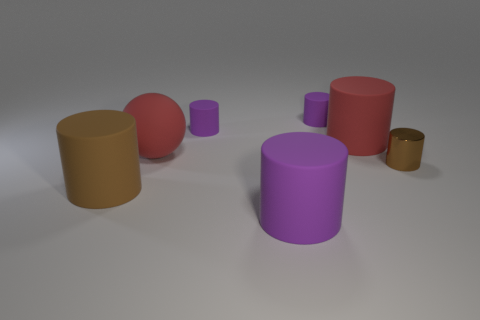There is a purple matte cylinder that is in front of the red rubber object in front of the red matte thing that is right of the large sphere; what size is it?
Your response must be concise. Large. How many other small objects have the same color as the shiny thing?
Give a very brief answer. 0. What number of objects are large brown metallic spheres or purple cylinders that are behind the large brown rubber object?
Provide a short and direct response. 2. The matte sphere has what color?
Make the answer very short. Red. What is the color of the big rubber cylinder in front of the big brown matte thing?
Provide a succinct answer. Purple. What number of large brown matte things are behind the large brown rubber cylinder that is in front of the small brown metallic object?
Give a very brief answer. 0. There is a brown matte thing; does it have the same size as the brown object on the right side of the large brown object?
Make the answer very short. No. Is there another brown shiny cylinder of the same size as the metal cylinder?
Make the answer very short. No. How many things are either large red rubber cylinders or big red rubber things?
Give a very brief answer. 2. There is a red rubber ball that is behind the brown metallic cylinder; is it the same size as the purple matte object in front of the red cylinder?
Offer a terse response. Yes. 